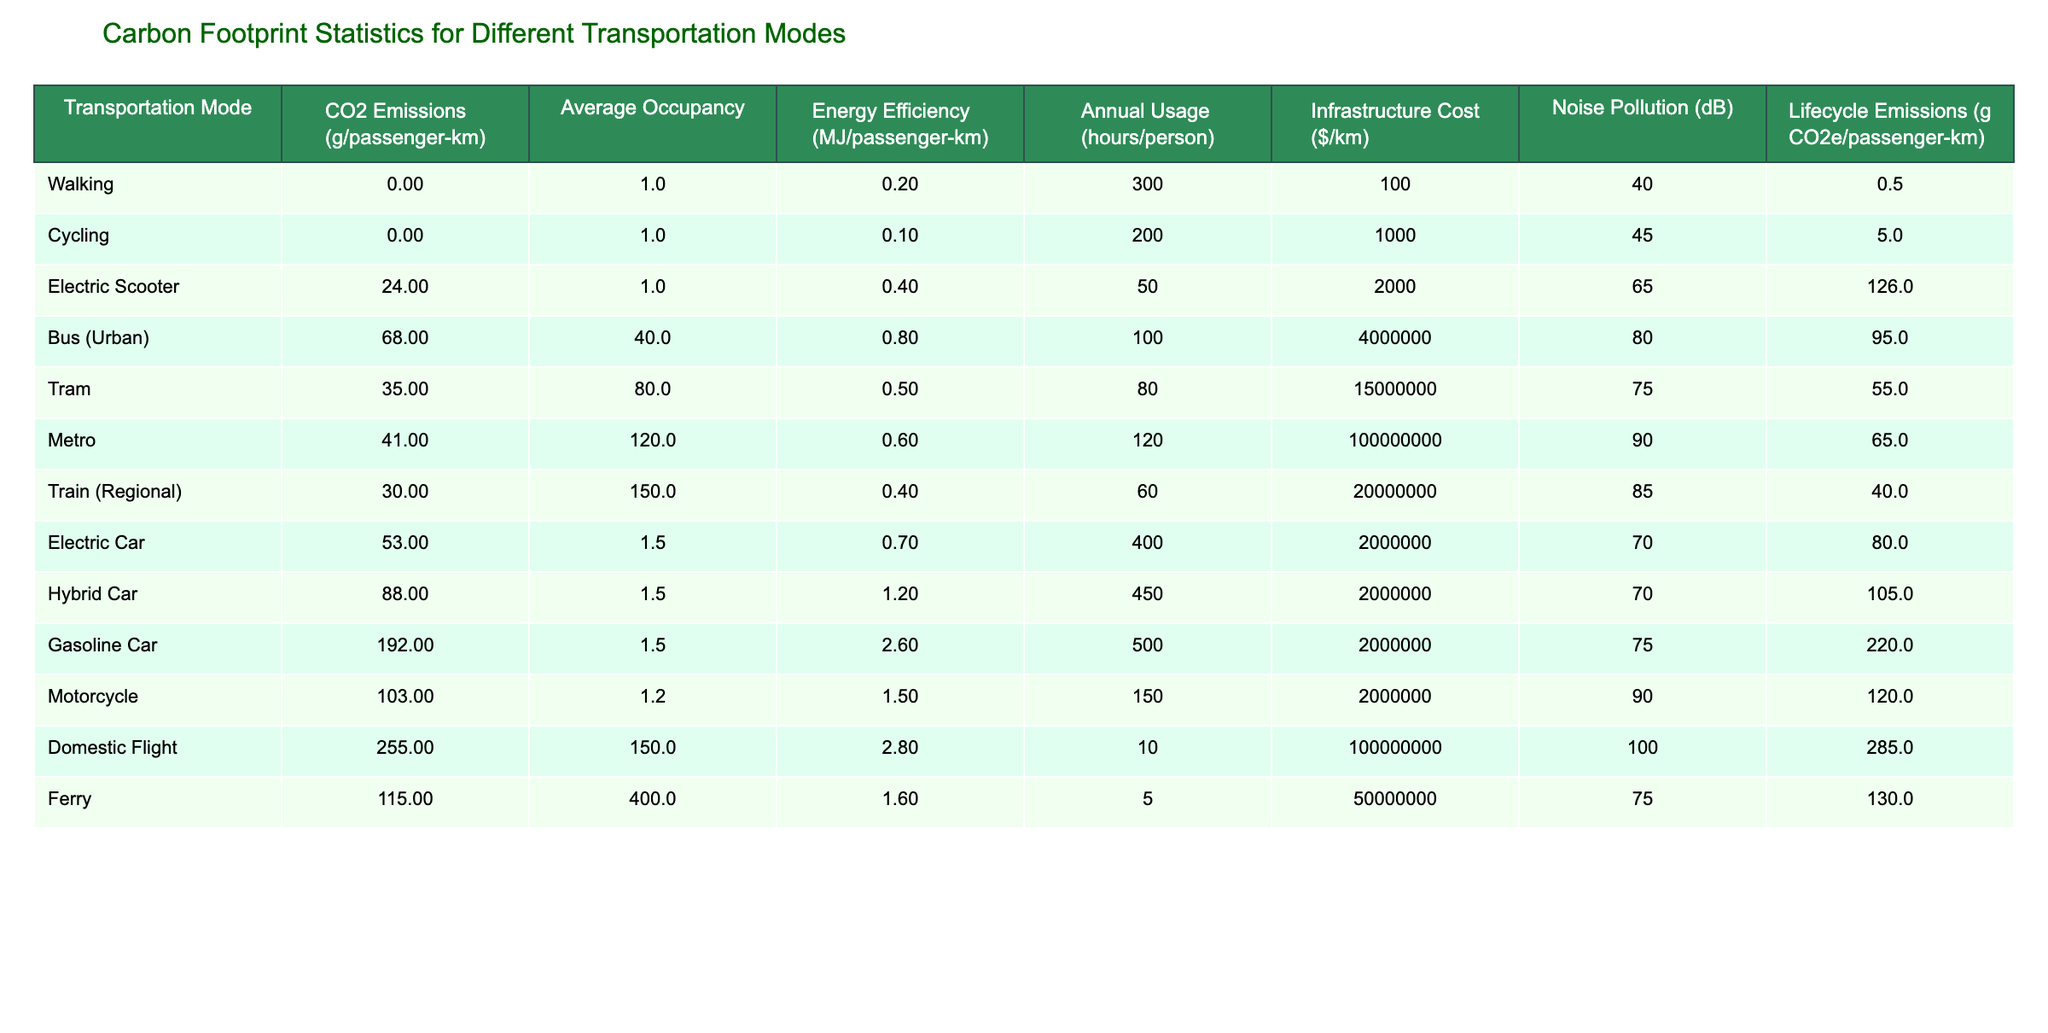What are the CO2 emissions of Cycling per passenger-km? The table shows that the CO2 emissions for Cycling is recorded as 0 g/passenger-km.
Answer: 0 Which transportation mode has the highest lifecycle emissions? By inspecting the table, the Gasoline Car has the highest lifecycle emissions at 220 g CO2e/passenger-km.
Answer: Gasoline Car What is the average occupancy rate for a Bus (Urban)? The average occupancy for a Bus (Urban) is listed as 40 passengers.
Answer: 40 How much more CO2 do Domestic Flights emit compared to Trams? Domestic Flights emit 255 g/passenger-km, while Trams emit 35 g/passenger-km. The difference is 255 - 35 = 220 g/passenger-km.
Answer: 220 Is the energy efficiency of an Electric Car greater than that of a Gasoline Car? The Electric Car has an energy efficiency of 0.7 MJ/passenger-km, while the Gasoline Car has 2.6 MJ/passenger-km. Since 0.7 is less than 2.6, the statement is false.
Answer: No What is the total annual usage in hours of a Hybrid Car and an Electric Car combined? The annual usage for a Hybrid Car is 450 hours and for an Electric Car is 400 hours. Adding these gives 450 + 400 = 850 hours.
Answer: 850 Which transportation mode has the least noise pollution, and what is its decibel level? Looking at the noise pollution column, Walking has the least noise pollution at 40 dB.
Answer: Walking, 40 dB What is the average CO2 emissions across all transportation modes listed in the table? By calculating the total CO2 emissions: (0 + 0 + 24 + 68 + 35 + 41 + 30 + 53 + 88 + 192 + 103 + 255 + 115) =  0 + 0 + 24 + 68 + 35 + 41 + 30 + 53 + 88 + 192 + 103 + 255 + 115 =  930. With 13 modes, the average is 930 / 13 = 71.54 g/passenger-km.
Answer: 71.54 Which has a higher infrastructure cost per kilometer, Metro or Domestic Flight? Metro costs $100,000,000/km and Domestic Flight costs $100,000,000/km as well. Since both are the same, neither has a higher cost.
Answer: Neither How does the CO2 emissions for Electric Scooters compare to those for motorcycles? Electric Scooters emit 24 g/passenger-km while Motorcycles emit 103 g/passenger-km. Therefore, Motorcycles emit more, as 103 is greater than 24.
Answer: Motorcycles emit more 